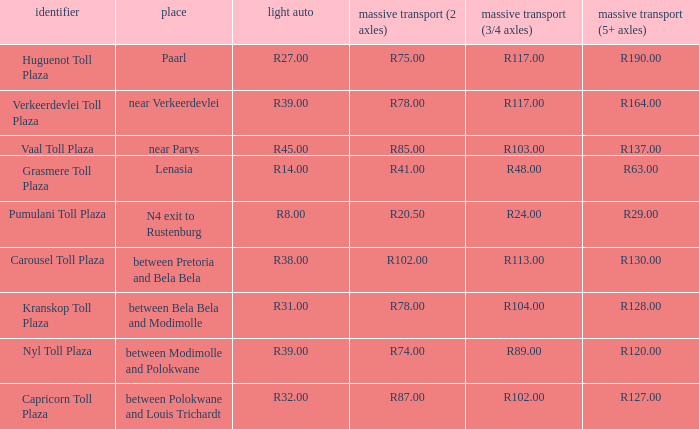What is the name of the plaza where the told for heavy vehicles with 2 axles is r20.50? Pumulani Toll Plaza. 